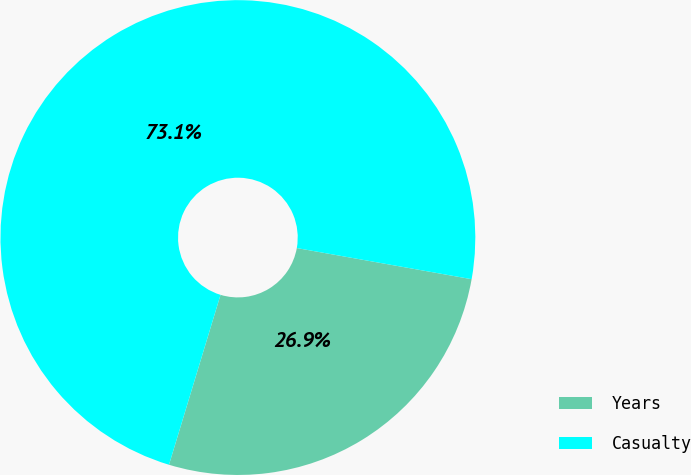Convert chart to OTSL. <chart><loc_0><loc_0><loc_500><loc_500><pie_chart><fcel>Years<fcel>Casualty<nl><fcel>26.88%<fcel>73.12%<nl></chart> 